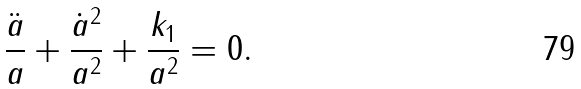Convert formula to latex. <formula><loc_0><loc_0><loc_500><loc_500>\frac { \ddot { a } } { a } + \frac { \dot { a } ^ { 2 } } { a ^ { 2 } } + \frac { k _ { 1 } } { a ^ { 2 } } = 0 .</formula> 